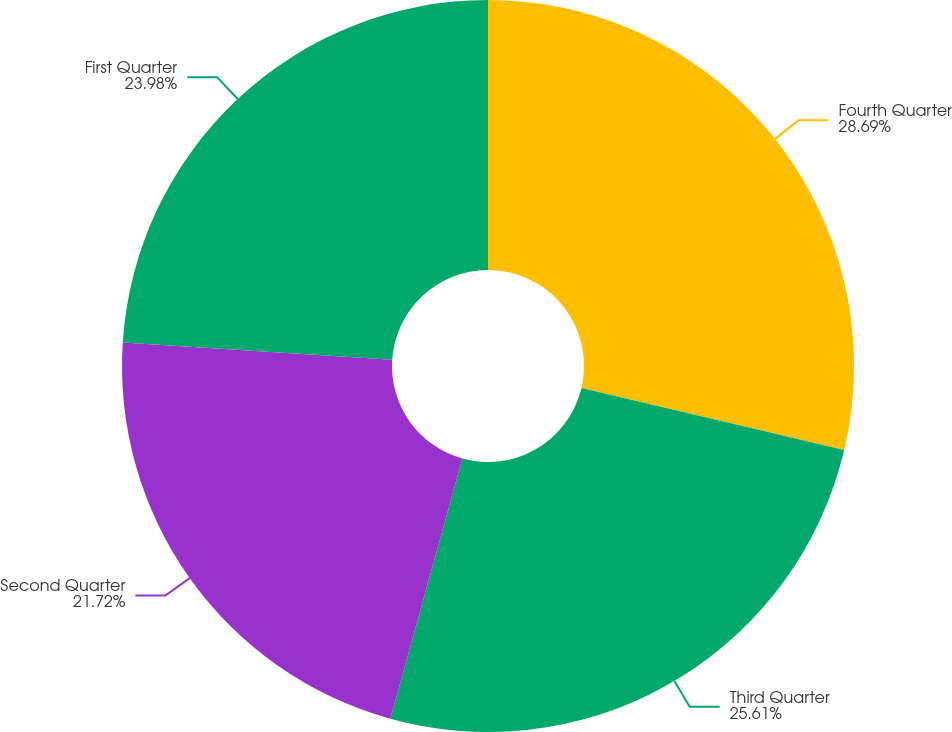Convert chart to OTSL. <chart><loc_0><loc_0><loc_500><loc_500><pie_chart><fcel>Fourth Quarter<fcel>Third Quarter<fcel>Second Quarter<fcel>First Quarter<nl><fcel>28.69%<fcel>25.61%<fcel>21.72%<fcel>23.98%<nl></chart> 